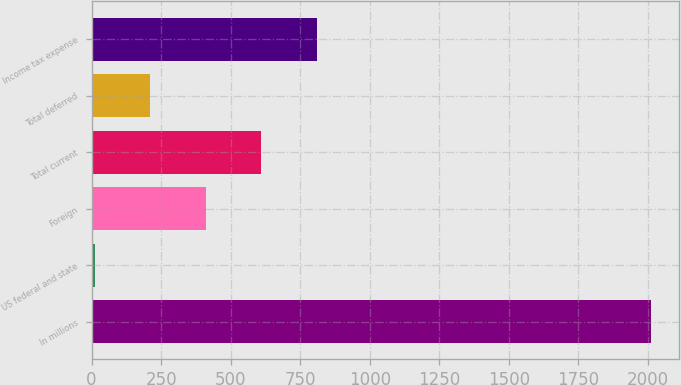<chart> <loc_0><loc_0><loc_500><loc_500><bar_chart><fcel>In millions<fcel>US federal and state<fcel>Foreign<fcel>Total current<fcel>Total deferred<fcel>Income tax expense<nl><fcel>2010<fcel>11<fcel>410.8<fcel>610.7<fcel>210.9<fcel>810.6<nl></chart> 